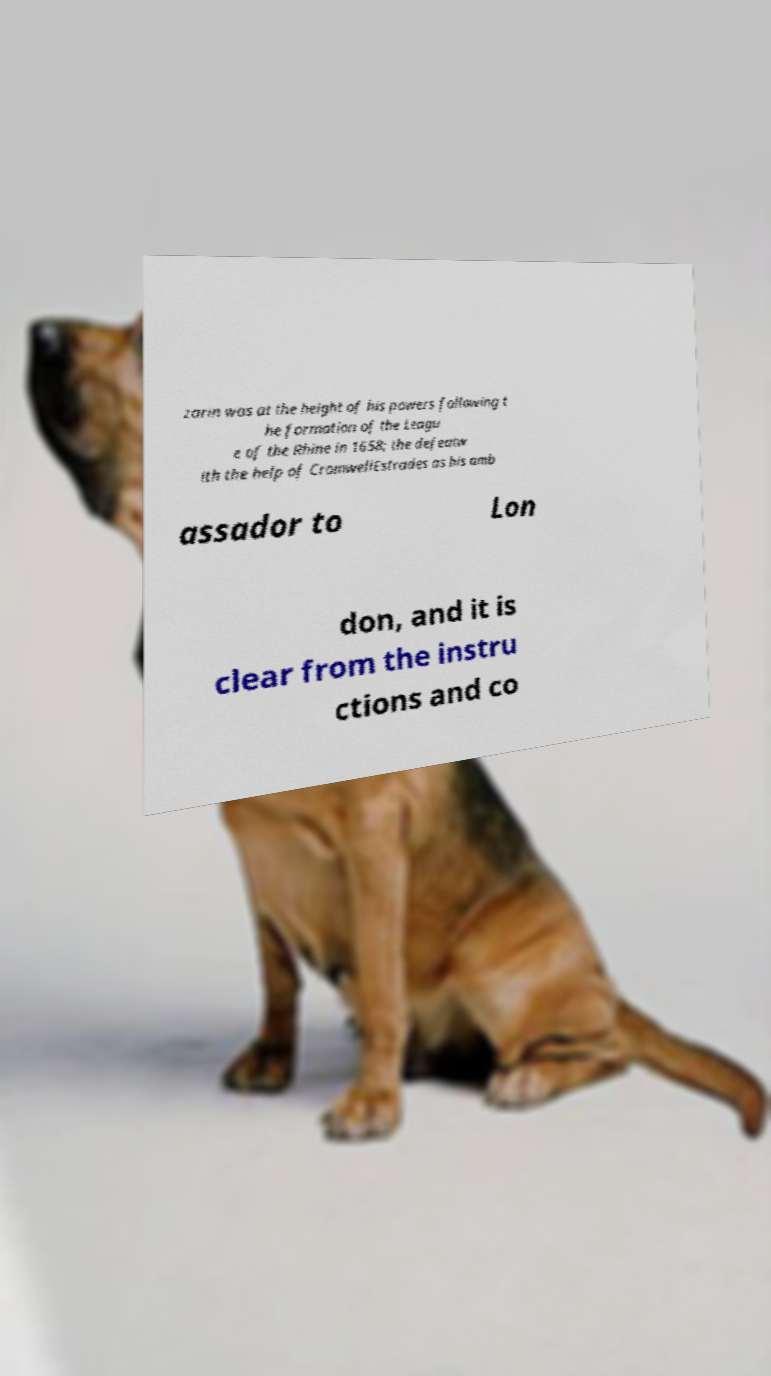Please read and relay the text visible in this image. What does it say? zarin was at the height of his powers following t he formation of the Leagu e of the Rhine in 1658; the defeatw ith the help of CromwellEstrades as his amb assador to Lon don, and it is clear from the instru ctions and co 